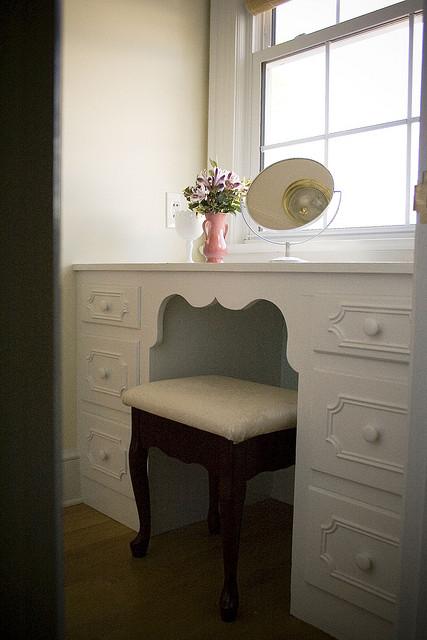What else is in the room?
Quick response, please. Desk. Is that a stool or a chair that's clearly visible in this picture?
Concise answer only. Stool. Are there any flowers in this picture?
Concise answer only. Yes. Which direction does the window slide?
Quick response, please. Up. Is there an electrical outlet anywhere?
Keep it brief. No. 